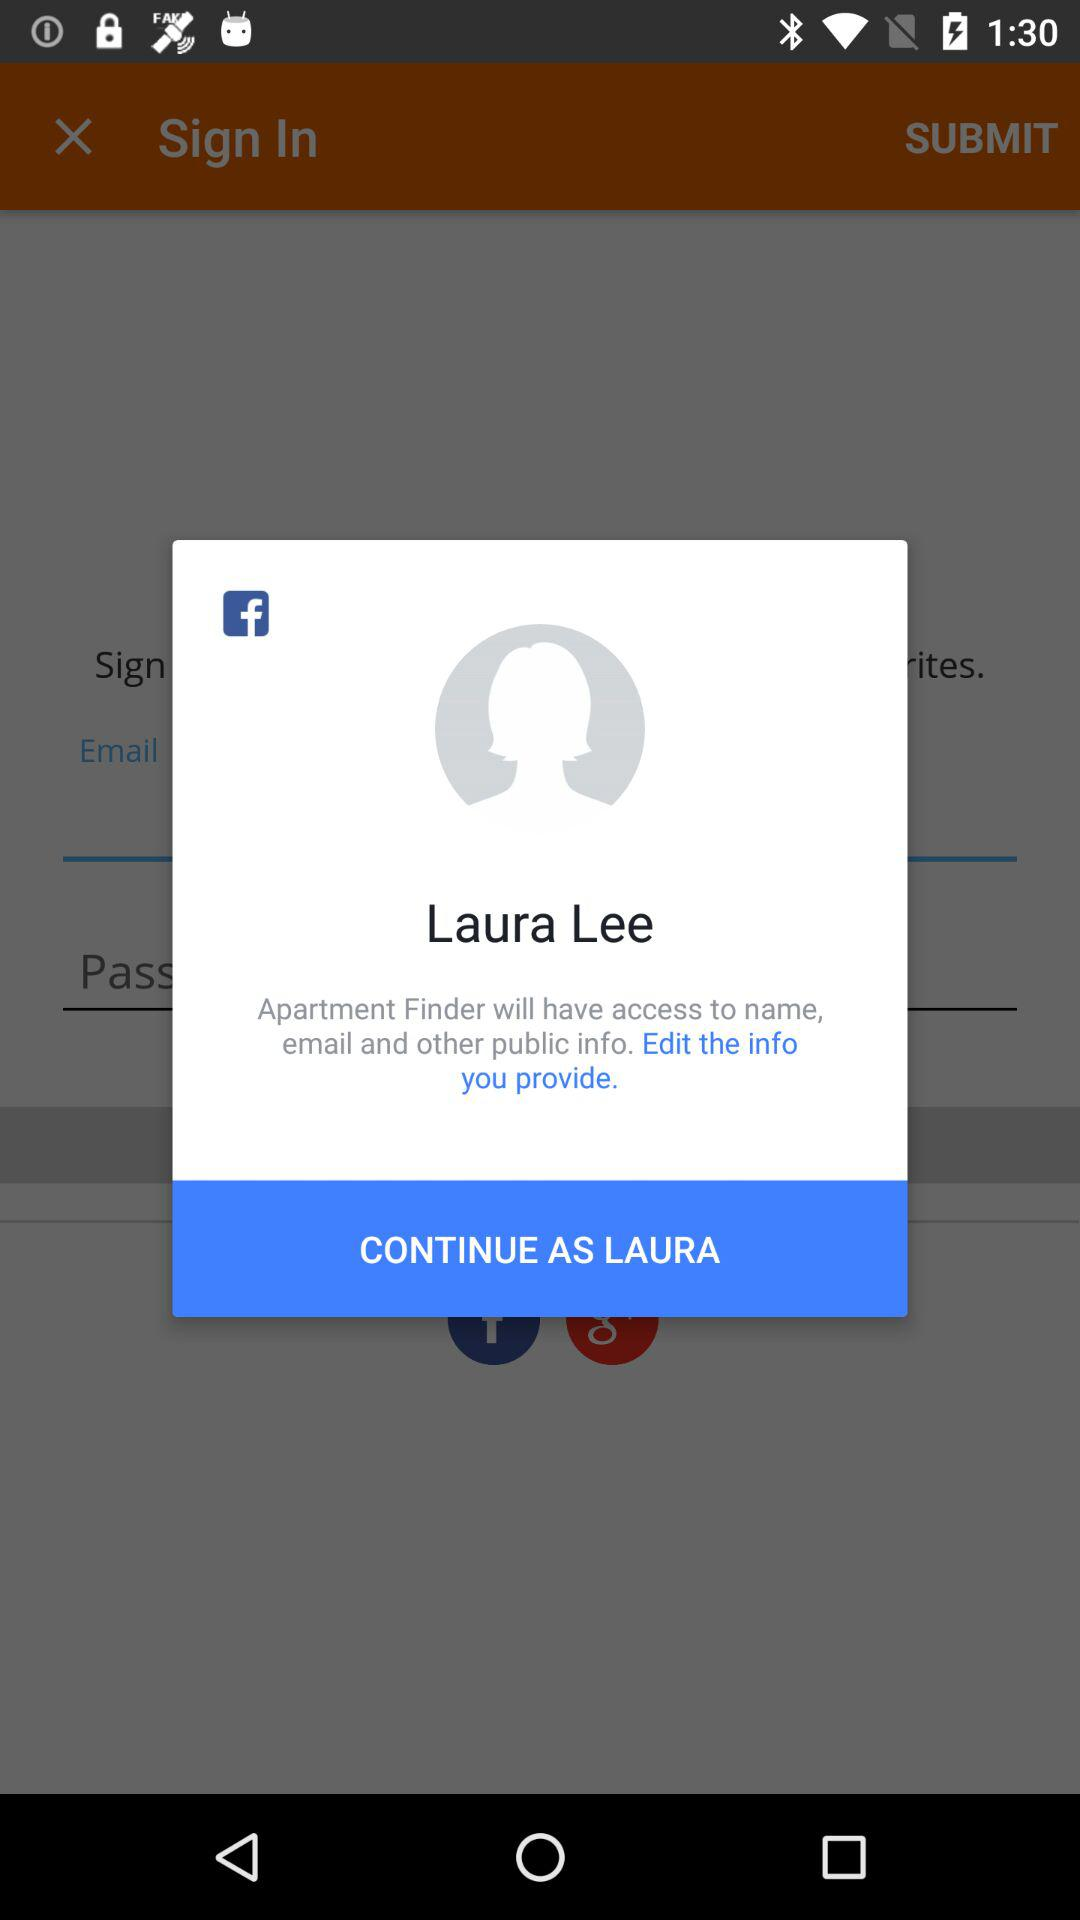What application is asking for permission? The application asking for permission is "Apartment Finder". 